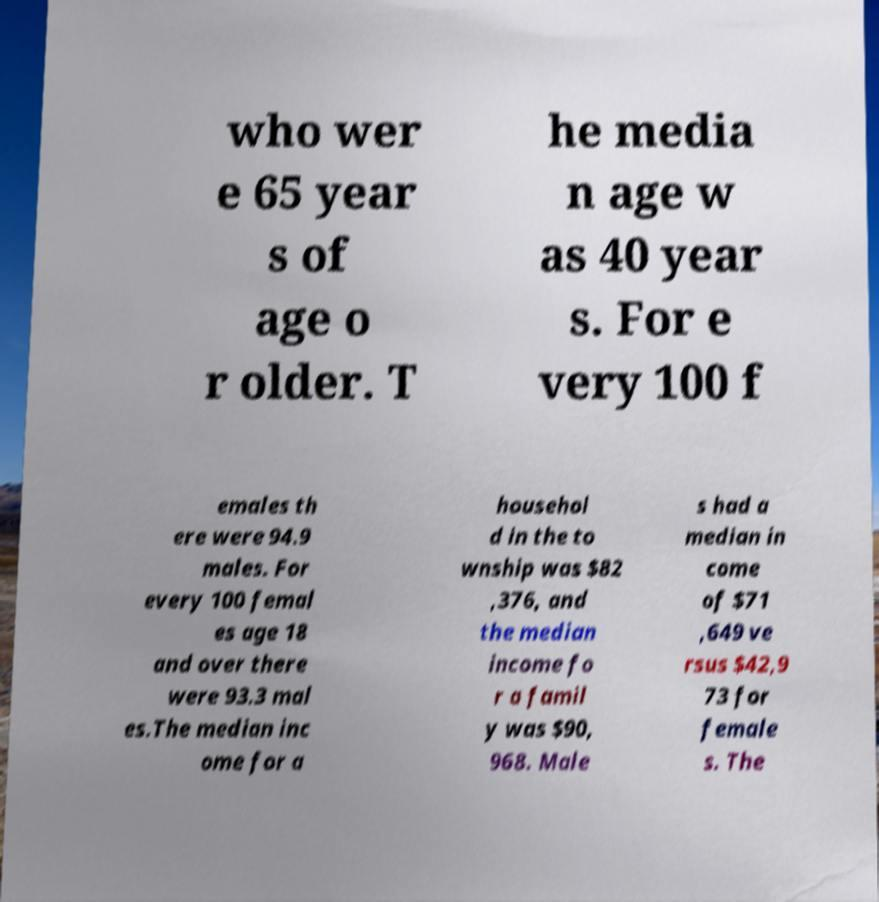Please read and relay the text visible in this image. What does it say? who wer e 65 year s of age o r older. T he media n age w as 40 year s. For e very 100 f emales th ere were 94.9 males. For every 100 femal es age 18 and over there were 93.3 mal es.The median inc ome for a househol d in the to wnship was $82 ,376, and the median income fo r a famil y was $90, 968. Male s had a median in come of $71 ,649 ve rsus $42,9 73 for female s. The 